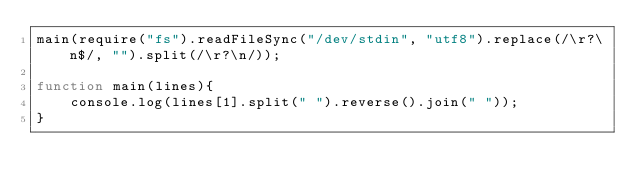Convert code to text. <code><loc_0><loc_0><loc_500><loc_500><_JavaScript_>main(require("fs").readFileSync("/dev/stdin", "utf8").replace(/\r?\n$/, "").split(/\r?\n/));

function main(lines){
	console.log(lines[1].split(" ").reverse().join(" "));
}</code> 